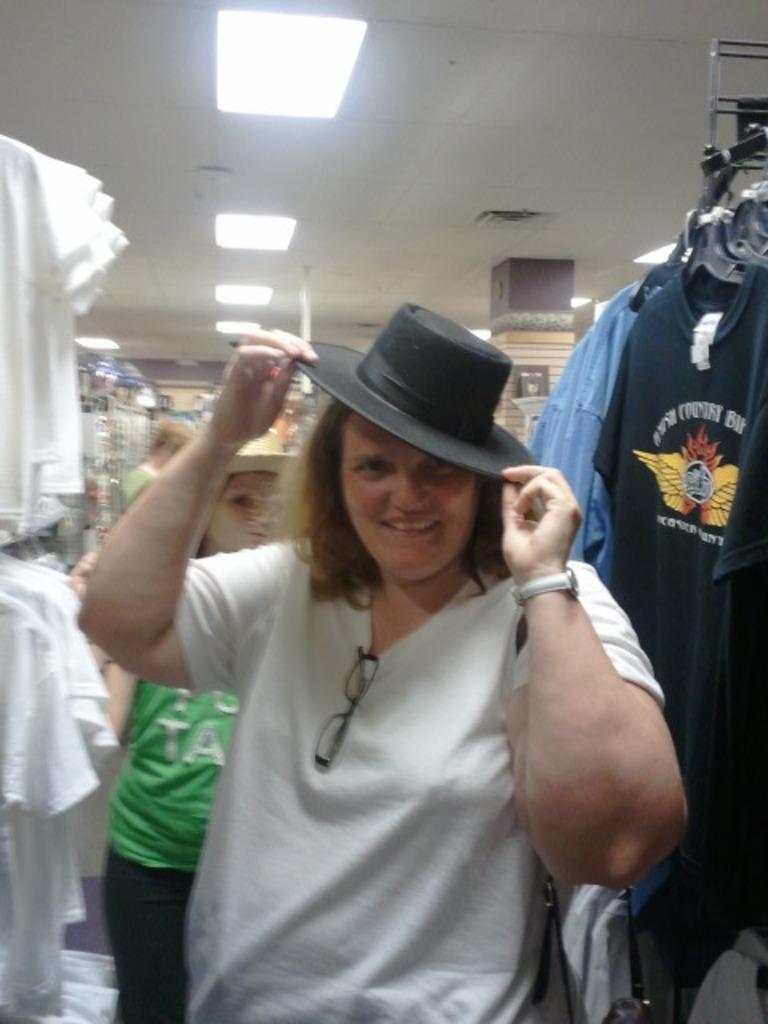Could you give a brief overview of what you see in this image? In the image we can see few persons and in the foreground a person is wearing a hat. On the right side, we can see a group of clothes hanged to an object. On the left side, we can see a group of shirts hanged. Behind the person we can see a pillar. At the top we can see a roof with lights. 